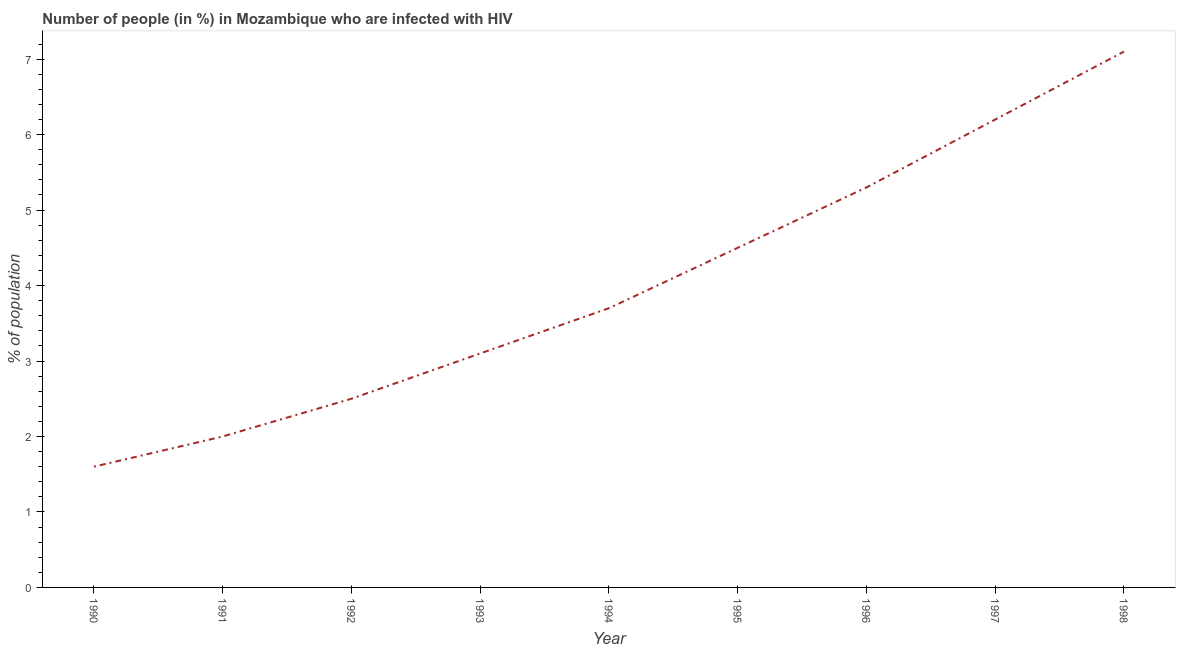Across all years, what is the maximum number of people infected with hiv?
Make the answer very short. 7.1. What is the sum of the number of people infected with hiv?
Provide a short and direct response. 36. What is the average number of people infected with hiv per year?
Your answer should be compact. 4. In how many years, is the number of people infected with hiv greater than 2.4 %?
Your answer should be compact. 7. Do a majority of the years between 1994 and 1993 (inclusive) have number of people infected with hiv greater than 5 %?
Your answer should be very brief. No. Is the number of people infected with hiv in 1990 less than that in 1992?
Your answer should be very brief. Yes. Is the difference between the number of people infected with hiv in 1990 and 1996 greater than the difference between any two years?
Make the answer very short. No. What is the difference between the highest and the second highest number of people infected with hiv?
Keep it short and to the point. 0.9. What is the difference between the highest and the lowest number of people infected with hiv?
Your answer should be very brief. 5.5. Are the values on the major ticks of Y-axis written in scientific E-notation?
Your response must be concise. No. What is the title of the graph?
Your answer should be compact. Number of people (in %) in Mozambique who are infected with HIV. What is the label or title of the X-axis?
Ensure brevity in your answer.  Year. What is the label or title of the Y-axis?
Your answer should be compact. % of population. What is the % of population in 1991?
Ensure brevity in your answer.  2. What is the % of population of 1993?
Ensure brevity in your answer.  3.1. What is the % of population in 1994?
Make the answer very short. 3.7. What is the % of population of 1996?
Your answer should be very brief. 5.3. What is the difference between the % of population in 1990 and 1992?
Your answer should be very brief. -0.9. What is the difference between the % of population in 1990 and 1993?
Your answer should be very brief. -1.5. What is the difference between the % of population in 1990 and 1998?
Your answer should be very brief. -5.5. What is the difference between the % of population in 1991 and 1992?
Your answer should be very brief. -0.5. What is the difference between the % of population in 1991 and 1993?
Your answer should be compact. -1.1. What is the difference between the % of population in 1991 and 1996?
Your answer should be compact. -3.3. What is the difference between the % of population in 1992 and 1994?
Your answer should be very brief. -1.2. What is the difference between the % of population in 1992 and 1996?
Give a very brief answer. -2.8. What is the difference between the % of population in 1992 and 1998?
Make the answer very short. -4.6. What is the difference between the % of population in 1993 and 1994?
Give a very brief answer. -0.6. What is the difference between the % of population in 1993 and 1995?
Provide a short and direct response. -1.4. What is the difference between the % of population in 1993 and 1998?
Your answer should be very brief. -4. What is the difference between the % of population in 1994 and 1995?
Give a very brief answer. -0.8. What is the difference between the % of population in 1995 and 1996?
Ensure brevity in your answer.  -0.8. What is the difference between the % of population in 1995 and 1997?
Your response must be concise. -1.7. What is the ratio of the % of population in 1990 to that in 1992?
Ensure brevity in your answer.  0.64. What is the ratio of the % of population in 1990 to that in 1993?
Ensure brevity in your answer.  0.52. What is the ratio of the % of population in 1990 to that in 1994?
Offer a very short reply. 0.43. What is the ratio of the % of population in 1990 to that in 1995?
Make the answer very short. 0.36. What is the ratio of the % of population in 1990 to that in 1996?
Provide a short and direct response. 0.3. What is the ratio of the % of population in 1990 to that in 1997?
Ensure brevity in your answer.  0.26. What is the ratio of the % of population in 1990 to that in 1998?
Your answer should be compact. 0.23. What is the ratio of the % of population in 1991 to that in 1992?
Offer a very short reply. 0.8. What is the ratio of the % of population in 1991 to that in 1993?
Give a very brief answer. 0.65. What is the ratio of the % of population in 1991 to that in 1994?
Offer a terse response. 0.54. What is the ratio of the % of population in 1991 to that in 1995?
Give a very brief answer. 0.44. What is the ratio of the % of population in 1991 to that in 1996?
Offer a very short reply. 0.38. What is the ratio of the % of population in 1991 to that in 1997?
Offer a terse response. 0.32. What is the ratio of the % of population in 1991 to that in 1998?
Provide a succinct answer. 0.28. What is the ratio of the % of population in 1992 to that in 1993?
Give a very brief answer. 0.81. What is the ratio of the % of population in 1992 to that in 1994?
Offer a very short reply. 0.68. What is the ratio of the % of population in 1992 to that in 1995?
Ensure brevity in your answer.  0.56. What is the ratio of the % of population in 1992 to that in 1996?
Ensure brevity in your answer.  0.47. What is the ratio of the % of population in 1992 to that in 1997?
Give a very brief answer. 0.4. What is the ratio of the % of population in 1992 to that in 1998?
Your response must be concise. 0.35. What is the ratio of the % of population in 1993 to that in 1994?
Offer a terse response. 0.84. What is the ratio of the % of population in 1993 to that in 1995?
Provide a short and direct response. 0.69. What is the ratio of the % of population in 1993 to that in 1996?
Your answer should be very brief. 0.58. What is the ratio of the % of population in 1993 to that in 1998?
Give a very brief answer. 0.44. What is the ratio of the % of population in 1994 to that in 1995?
Provide a short and direct response. 0.82. What is the ratio of the % of population in 1994 to that in 1996?
Make the answer very short. 0.7. What is the ratio of the % of population in 1994 to that in 1997?
Give a very brief answer. 0.6. What is the ratio of the % of population in 1994 to that in 1998?
Keep it short and to the point. 0.52. What is the ratio of the % of population in 1995 to that in 1996?
Provide a short and direct response. 0.85. What is the ratio of the % of population in 1995 to that in 1997?
Your response must be concise. 0.73. What is the ratio of the % of population in 1995 to that in 1998?
Your answer should be very brief. 0.63. What is the ratio of the % of population in 1996 to that in 1997?
Ensure brevity in your answer.  0.85. What is the ratio of the % of population in 1996 to that in 1998?
Offer a very short reply. 0.75. What is the ratio of the % of population in 1997 to that in 1998?
Offer a terse response. 0.87. 